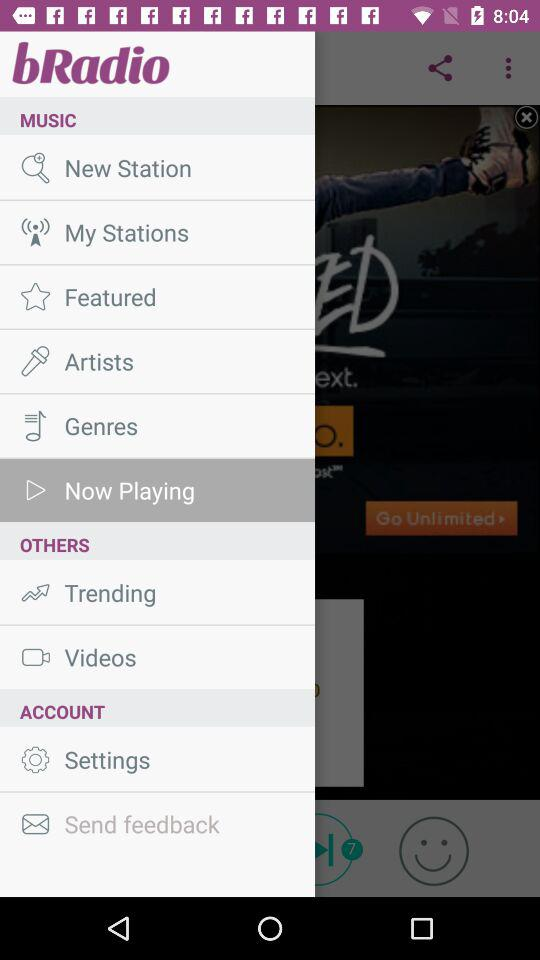Which option is selected in Music? The selected option is "Now Playing". 